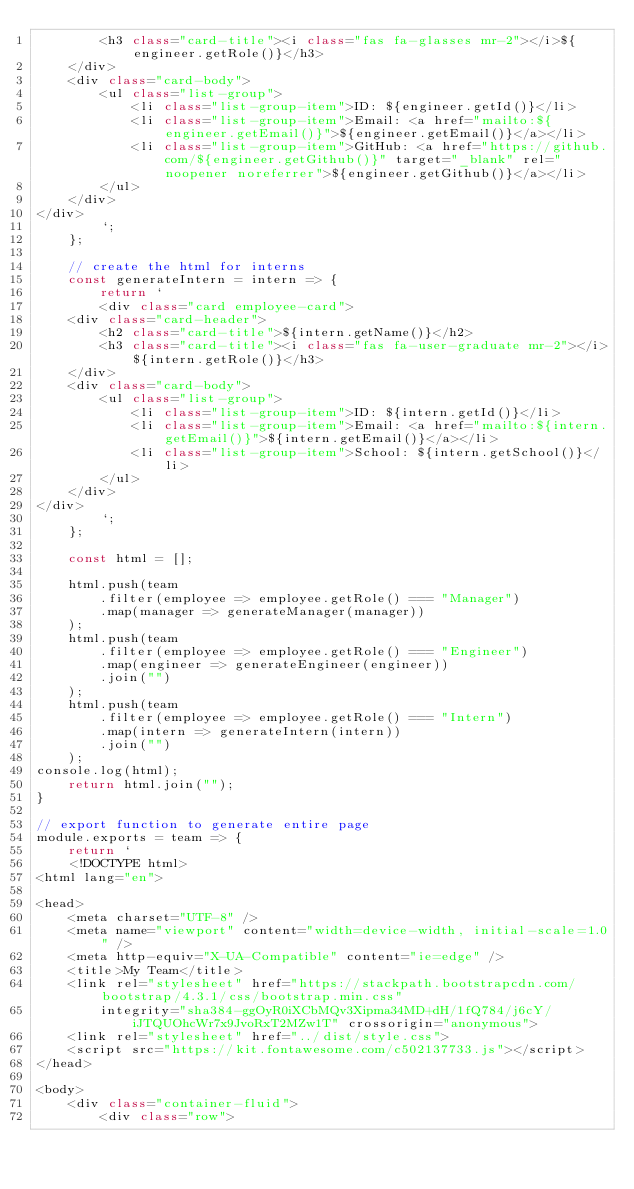<code> <loc_0><loc_0><loc_500><loc_500><_JavaScript_>        <h3 class="card-title"><i class="fas fa-glasses mr-2"></i>${engineer.getRole()}</h3>
    </div>
    <div class="card-body">
        <ul class="list-group">
            <li class="list-group-item">ID: ${engineer.getId()}</li>
            <li class="list-group-item">Email: <a href="mailto:${engineer.getEmail()}">${engineer.getEmail()}</a></li>
            <li class="list-group-item">GitHub: <a href="https://github.com/${engineer.getGithub()}" target="_blank" rel="noopener noreferrer">${engineer.getGithub()}</a></li>
        </ul>
    </div>
</div>
        `;
    };

    // create the html for interns
    const generateIntern = intern => {
        return `
        <div class="card employee-card">
    <div class="card-header">
        <h2 class="card-title">${intern.getName()}</h2>
        <h3 class="card-title"><i class="fas fa-user-graduate mr-2"></i>${intern.getRole()}</h3>
    </div>
    <div class="card-body">
        <ul class="list-group">
            <li class="list-group-item">ID: ${intern.getId()}</li>
            <li class="list-group-item">Email: <a href="mailto:${intern.getEmail()}">${intern.getEmail()}</a></li>
            <li class="list-group-item">School: ${intern.getSchool()}</li>
        </ul>
    </div>
</div>
        `;
    };

    const html = [];

    html.push(team
        .filter(employee => employee.getRole() === "Manager")
        .map(manager => generateManager(manager))
    );
    html.push(team
        .filter(employee => employee.getRole() === "Engineer")
        .map(engineer => generateEngineer(engineer))
        .join("")
    );
    html.push(team
        .filter(employee => employee.getRole() === "Intern")
        .map(intern => generateIntern(intern))
        .join("")
    );
console.log(html);
    return html.join("");
}

// export function to generate entire page
module.exports = team => {
    return `
    <!DOCTYPE html>
<html lang="en">

<head>
    <meta charset="UTF-8" />
    <meta name="viewport" content="width=device-width, initial-scale=1.0" />
    <meta http-equiv="X-UA-Compatible" content="ie=edge" />
    <title>My Team</title>
    <link rel="stylesheet" href="https://stackpath.bootstrapcdn.com/bootstrap/4.3.1/css/bootstrap.min.css"
        integrity="sha384-ggOyR0iXCbMQv3Xipma34MD+dH/1fQ784/j6cY/iJTQUOhcWr7x9JvoRxT2MZw1T" crossorigin="anonymous">
    <link rel="stylesheet" href="../dist/style.css">
    <script src="https://kit.fontawesome.com/c502137733.js"></script>
</head>

<body>
    <div class="container-fluid">
        <div class="row"></code> 